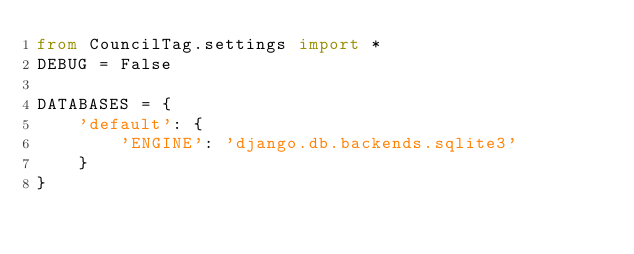<code> <loc_0><loc_0><loc_500><loc_500><_Python_>from CouncilTag.settings import *
DEBUG = False

DATABASES = {
    'default': {
        'ENGINE': 'django.db.backends.sqlite3'
    }
}</code> 